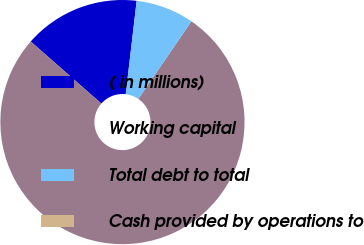Convert chart. <chart><loc_0><loc_0><loc_500><loc_500><pie_chart><fcel>( in millions)<fcel>Working capital<fcel>Total debt to total<fcel>Cash provided by operations to<nl><fcel>15.39%<fcel>76.92%<fcel>7.69%<fcel>0.0%<nl></chart> 